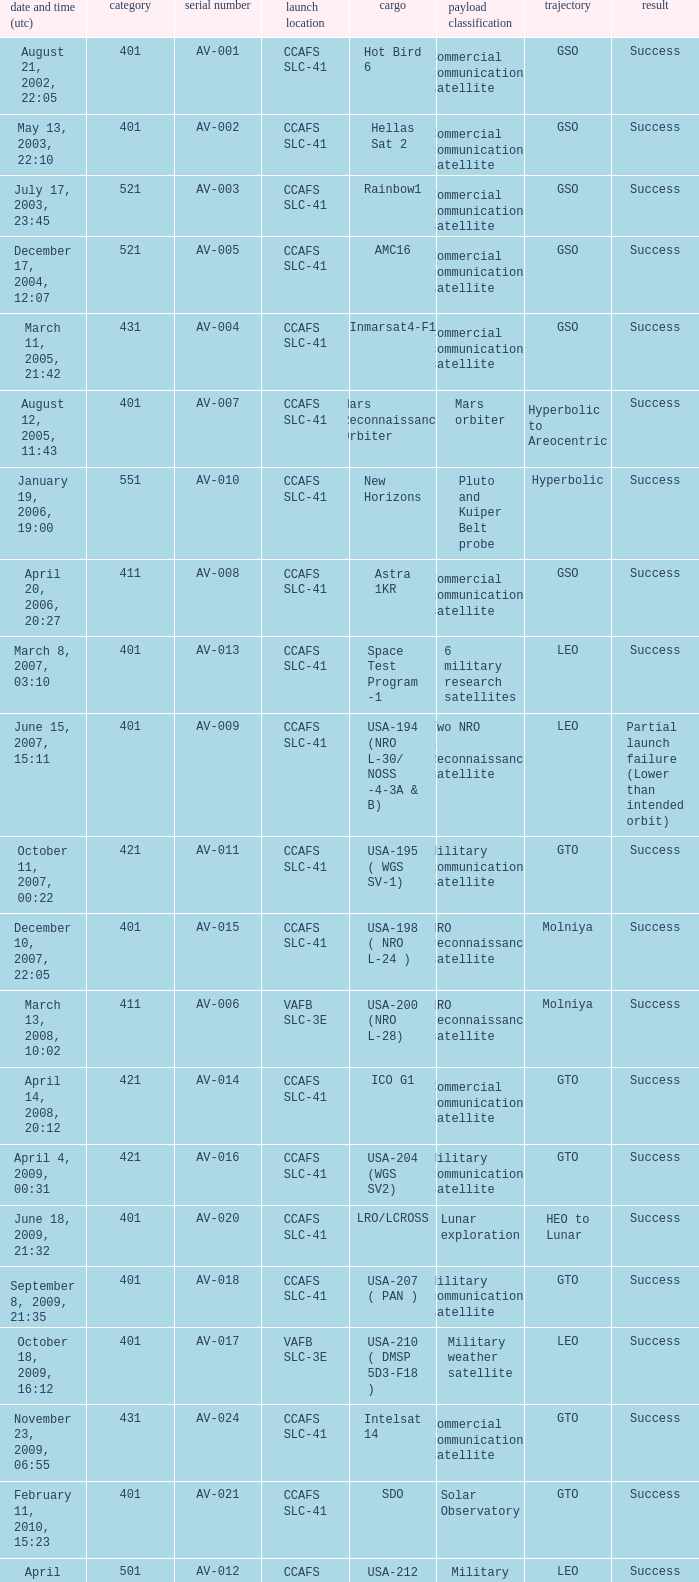What payload was on November 26, 2011, 15:02? Mars rover. 